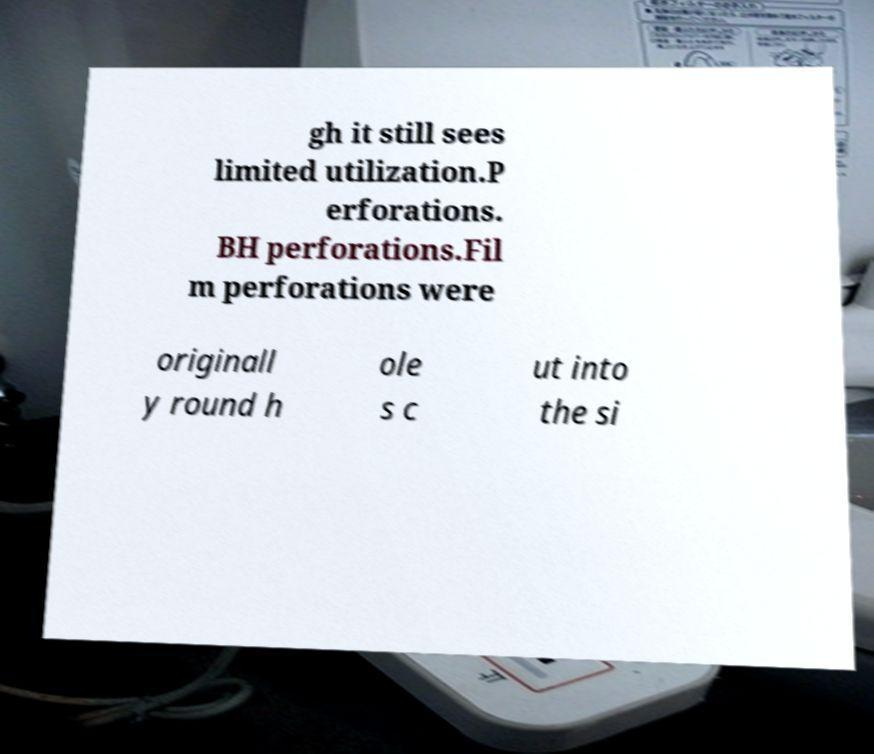There's text embedded in this image that I need extracted. Can you transcribe it verbatim? gh it still sees limited utilization.P erforations. BH perforations.Fil m perforations were originall y round h ole s c ut into the si 